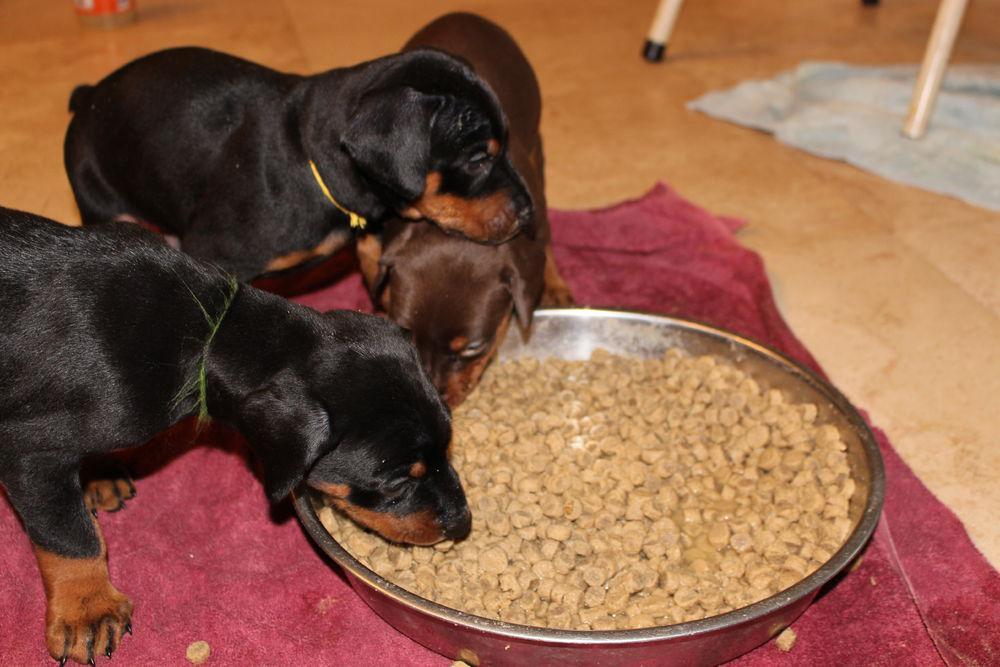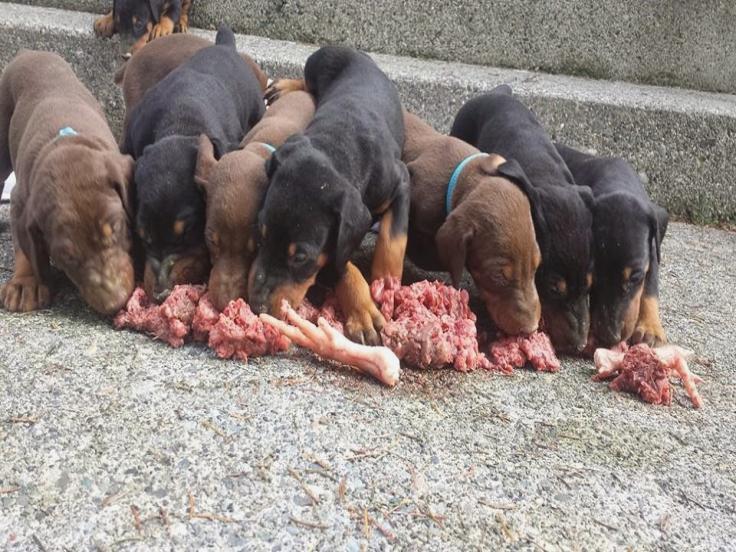The first image is the image on the left, the second image is the image on the right. Examine the images to the left and right. Is the description "Multiple puppies are standing around at least part of a round silver bowl shape in at least one image." accurate? Answer yes or no. Yes. The first image is the image on the left, the second image is the image on the right. Considering the images on both sides, is "Dogs are eating out of a bowl." valid? Answer yes or no. Yes. 